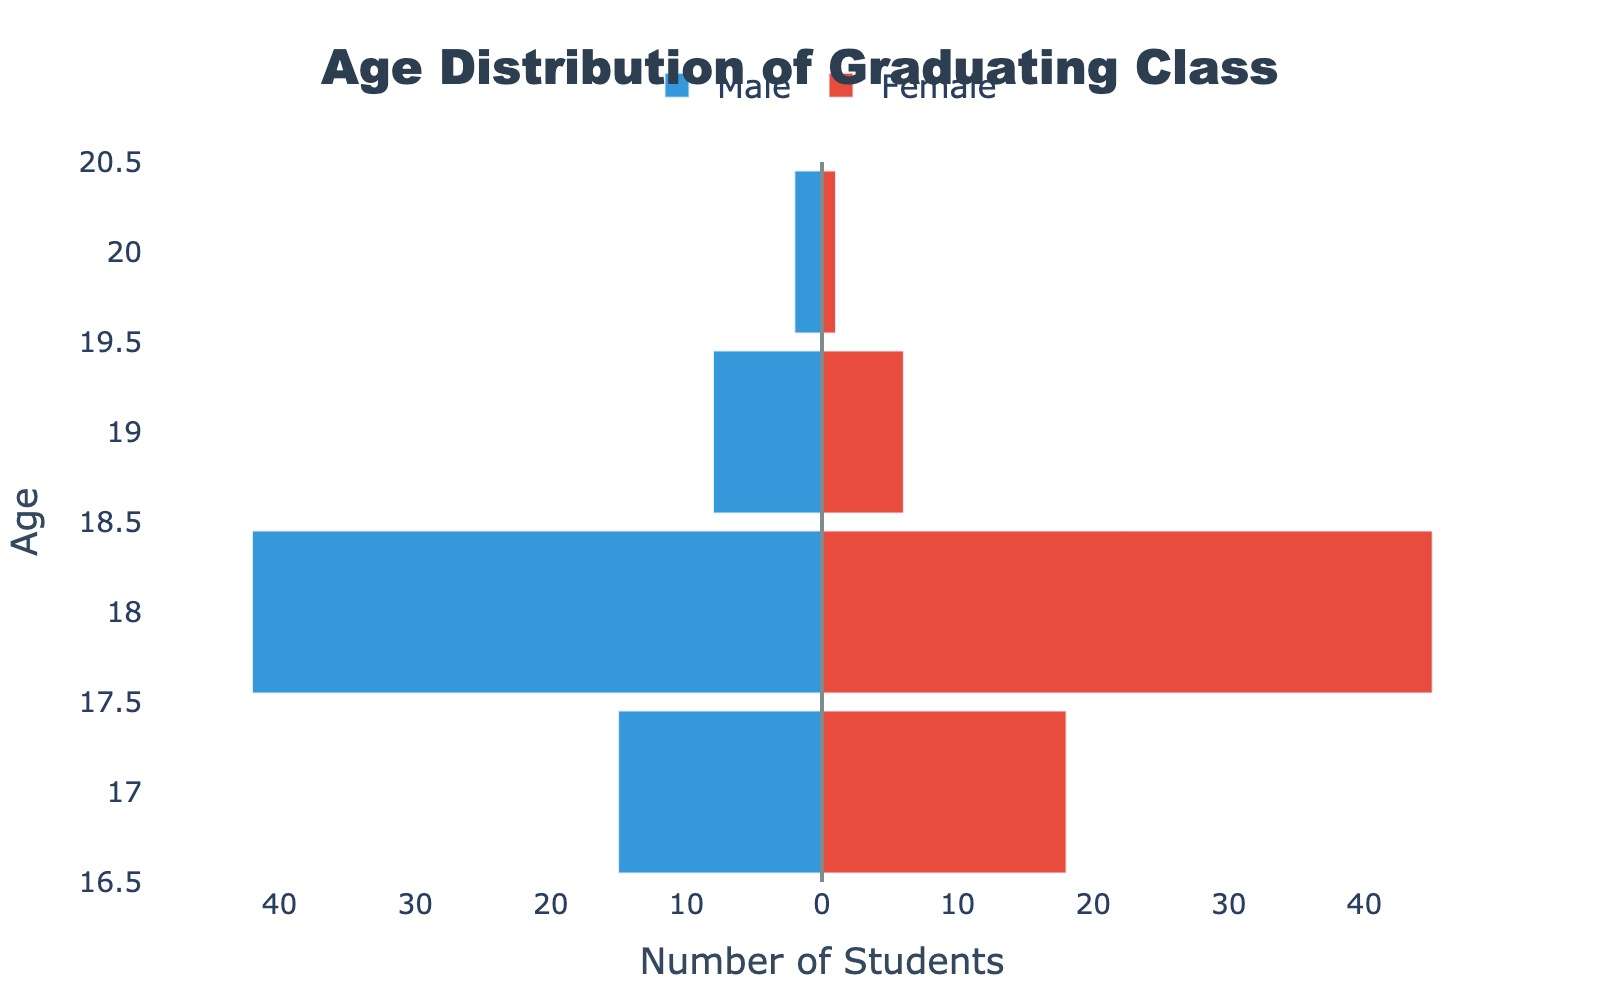What is the title of the plot? The title of the plot is located at the top center and it indicates what the plot represents.
Answer: Age Distribution of Graduating Class How many 18-year-old male students are there in the graduating class? The male students are represented by the blue bars on the left side of the graph. The length of the bar at age 18 corresponds to the number of male students, which reaches up to -42.
Answer: 42 How many more 17-year-old female students are there than 17-year-old male students? The number of 17-year-old female students is represented by the red bar at age 17, which is 18. The corresponding blue bar shows 15 male students. The difference is 18 - 15.
Answer: 3 What is the total number of 19-year-old students in the graduating class? Add the number of 19-year-old male and female students: 8 (male) + 6 (female) = 14.
Answer: 14 Compare the number of male and female students who are 20 years old. Which gender has more students, and by how many? There are 2 male students and 1 female student who are 20 years old. Subtract the number of female students from male students: 2 - 1.
Answer: Male, 1 more Which age group has the highest number of students and how many students are in that age group? Look at the age group where the sum of the male and female students (represented by the lengths of the bars) is the highest. Age 18 has 42 male students and 45 female students, totaling 87 students.
Answer: 18, 87 What is the age range of the students in the graduating class? The age range can be determined from the vertical axis, which spans from the minimum age of 17 to the maximum age of 20.
Answer: 17 to 20 Do any ages have an equal number of male and female students? Scan the bars to see if any pair of bars at each age have the same length. There are no ages with equal numbers of male and female students.
Answer: No Which gender has more students overall in the graduating class? Sum the total number of male students (15 + 42 + 8 + 2 = 67) and female students (18 + 45 + 6 + 1 = 70). Compare the totals.
Answer: Female What is the difference between the number of 18-year-old male and female students? Subtract the number of 18-year-old male students from the number of female students: 45 - 42.
Answer: 3 